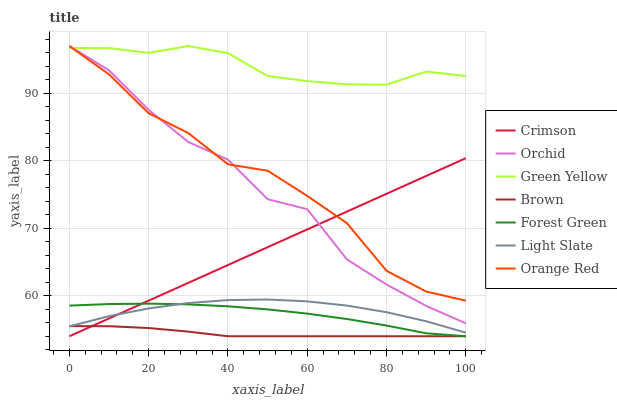Does Brown have the minimum area under the curve?
Answer yes or no. Yes. Does Green Yellow have the maximum area under the curve?
Answer yes or no. Yes. Does Light Slate have the minimum area under the curve?
Answer yes or no. No. Does Light Slate have the maximum area under the curve?
Answer yes or no. No. Is Crimson the smoothest?
Answer yes or no. Yes. Is Orchid the roughest?
Answer yes or no. Yes. Is Light Slate the smoothest?
Answer yes or no. No. Is Light Slate the roughest?
Answer yes or no. No. Does Brown have the lowest value?
Answer yes or no. Yes. Does Light Slate have the lowest value?
Answer yes or no. No. Does Orchid have the highest value?
Answer yes or no. Yes. Does Light Slate have the highest value?
Answer yes or no. No. Is Forest Green less than Orchid?
Answer yes or no. Yes. Is Orange Red greater than Brown?
Answer yes or no. Yes. Does Light Slate intersect Crimson?
Answer yes or no. Yes. Is Light Slate less than Crimson?
Answer yes or no. No. Is Light Slate greater than Crimson?
Answer yes or no. No. Does Forest Green intersect Orchid?
Answer yes or no. No. 